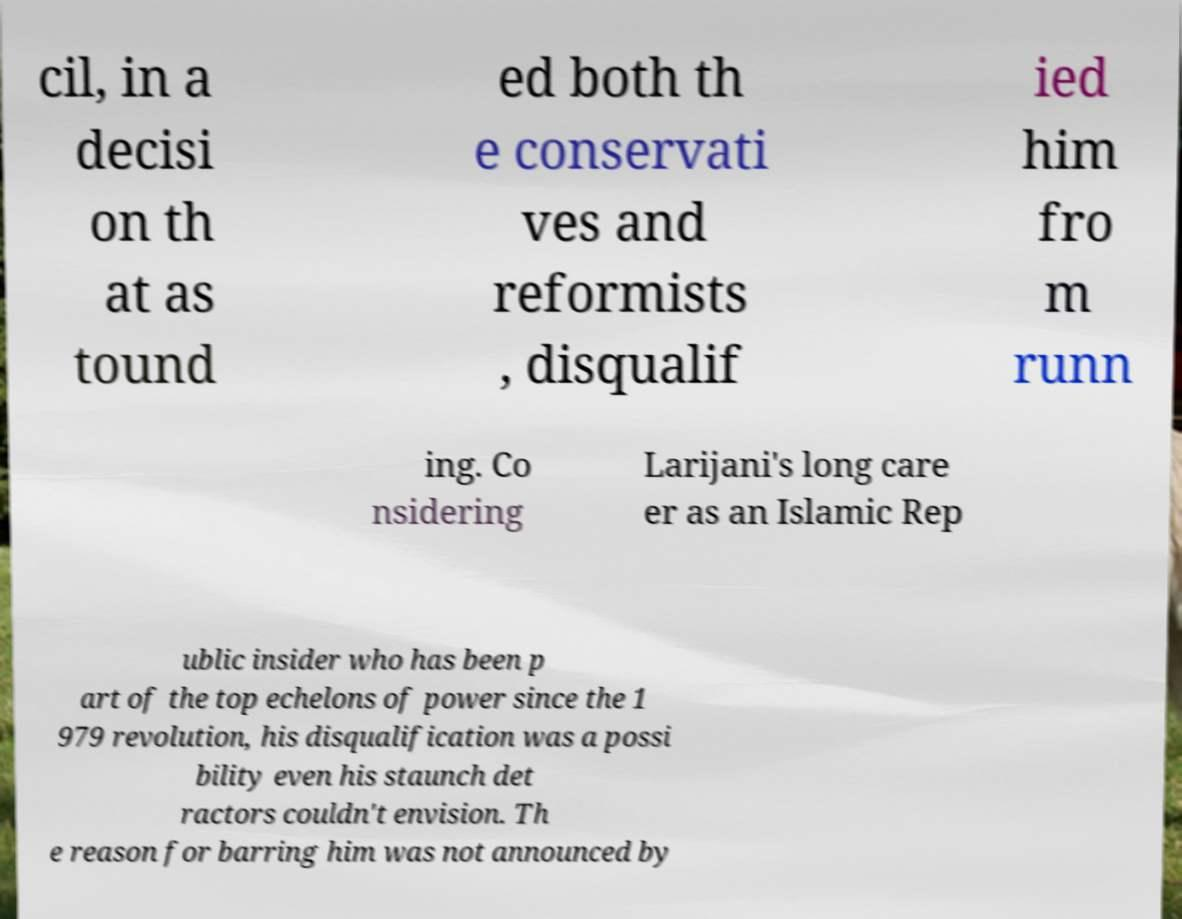I need the written content from this picture converted into text. Can you do that? cil, in a decisi on th at as tound ed both th e conservati ves and reformists , disqualif ied him fro m runn ing. Co nsidering Larijani's long care er as an Islamic Rep ublic insider who has been p art of the top echelons of power since the 1 979 revolution, his disqualification was a possi bility even his staunch det ractors couldn't envision. Th e reason for barring him was not announced by 